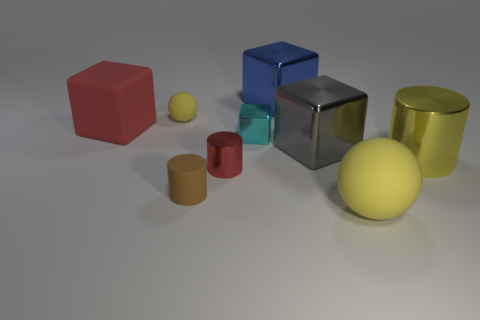Are there more gray metal objects behind the brown cylinder than large purple metal cylinders?
Make the answer very short. Yes. There is a cyan thing; is it the same shape as the small rubber object in front of the red rubber object?
Make the answer very short. No. What is the size of the yellow metal object that is the same shape as the small brown rubber object?
Offer a terse response. Large. Is the number of yellow objects greater than the number of things?
Your response must be concise. No. Is the shape of the small red metal object the same as the tiny brown matte thing?
Offer a terse response. Yes. There is a big thing on the left side of the tiny brown cylinder that is behind the large sphere; what is its material?
Ensure brevity in your answer.  Rubber. There is a cylinder that is the same color as the matte block; what is it made of?
Provide a short and direct response. Metal. Does the red rubber object have the same size as the blue object?
Provide a short and direct response. Yes. There is a shiny thing behind the large red block; is there a large metallic cylinder in front of it?
Give a very brief answer. Yes. What size is the other ball that is the same color as the big ball?
Provide a short and direct response. Small. 